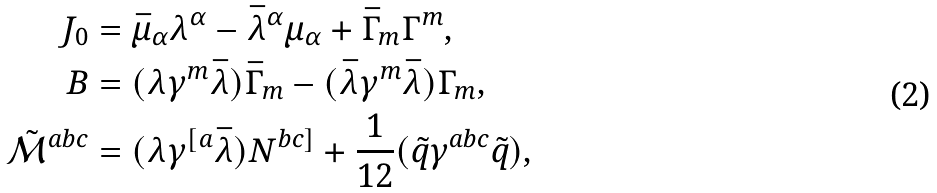Convert formula to latex. <formula><loc_0><loc_0><loc_500><loc_500>J _ { 0 } & = \bar { \mu } _ { \alpha } \lambda ^ { \alpha } - \bar { \lambda } ^ { \alpha } \mu _ { \alpha } + \bar { \Gamma } _ { m } \Gamma ^ { m } , \\ B & = ( \lambda \gamma ^ { m } \bar { \lambda } ) \bar { \Gamma } _ { m } - ( \bar { \lambda } \gamma ^ { m } \bar { \lambda } ) \Gamma _ { m } , \\ \tilde { \mathcal { M } } ^ { a b c } & = ( \lambda \gamma ^ { [ a } \bar { \lambda } ) N ^ { b c ] } + \frac { 1 } { 1 2 } ( \tilde { q } \gamma ^ { a b c } \tilde { q } ) ,</formula> 